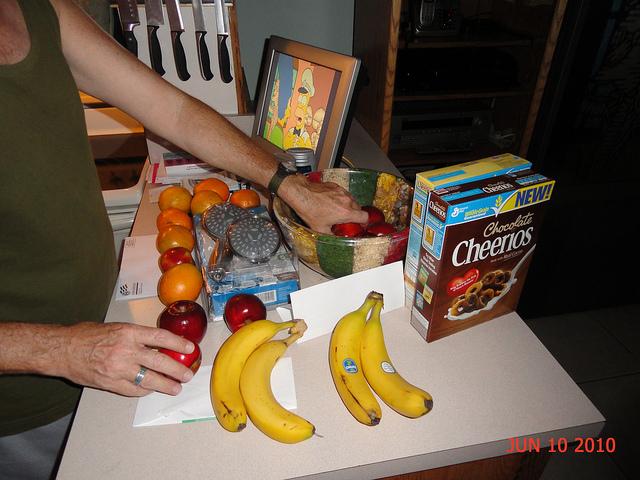Are these greasy?
Quick response, please. No. Is the banana fresh?
Answer briefly. Yes. What kind of food is in the yellow box?
Concise answer only. Cereal. What year was this photo taken?
Give a very brief answer. 2010. What is the date stamp on this photo?
Answer briefly. June 10 2010. How many bananas are visible?
Quick response, please. 4. How many bananas are depicted?
Write a very short answer. 4. Is the box open?
Concise answer only. No. What color is the table?
Give a very brief answer. White. What fruit is next to the bananas?
Answer briefly. Apple. What metal tool on the counter called?
Give a very brief answer. Shower head. Is he trying to decide which pastry he wants to eat?
Keep it brief. No. Is the guy using sugar in the recipe?
Keep it brief. No. Is this a fruit of vegetable?
Answer briefly. Fruit. Is there parchment paper on the baking tray?
Write a very short answer. No. Is there a wrapped sandwich next to the banana?
Answer briefly. No. What is the date on the photo?
Concise answer only. June 10 2010. Is this an advertisement for bananas?
Keep it brief. No. Are there artichokes on the table?
Quick response, please. No. How many piece of fruit do you see?
Quick response, please. 18. What type of pie does it look like they are making?
Give a very brief answer. Fruit. Is the fruit whole or cut up?
Give a very brief answer. Whole. On what date was this photo taken?
Write a very short answer. June 10 2010. What cartoon is on the screen?
Keep it brief. Simpsons. What is she holding?
Short answer required. Apple. What is this person getting ready to make?
Write a very short answer. Breakfast. How many bananas is the person holding?
Write a very short answer. 0. What is the color of the man's shirt?
Be succinct. Green. Could you heat this meal in a microwave?
Keep it brief. No. Would a vegetarian eat this?
Keep it brief. Yes. What kind of cereal is on the table?
Answer briefly. Cheerios. How many bananas are there?
Short answer required. 4. How many boxes are there?
Short answer required. 2. 